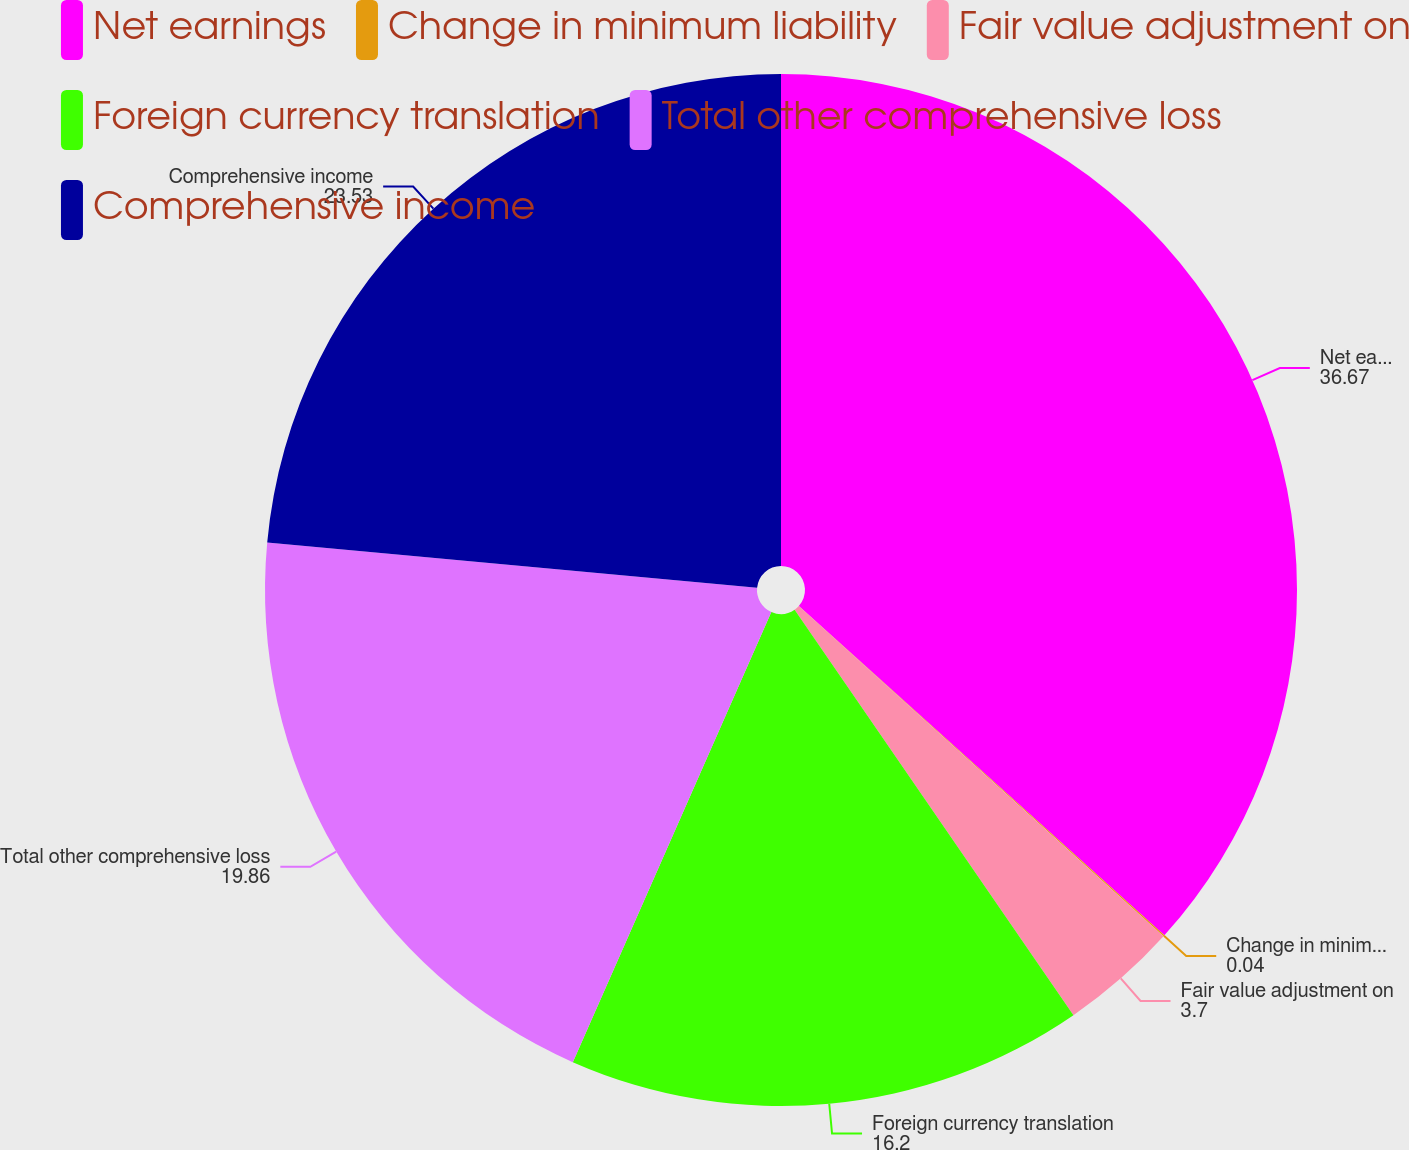Convert chart. <chart><loc_0><loc_0><loc_500><loc_500><pie_chart><fcel>Net earnings<fcel>Change in minimum liability<fcel>Fair value adjustment on<fcel>Foreign currency translation<fcel>Total other comprehensive loss<fcel>Comprehensive income<nl><fcel>36.67%<fcel>0.04%<fcel>3.7%<fcel>16.2%<fcel>19.86%<fcel>23.53%<nl></chart> 